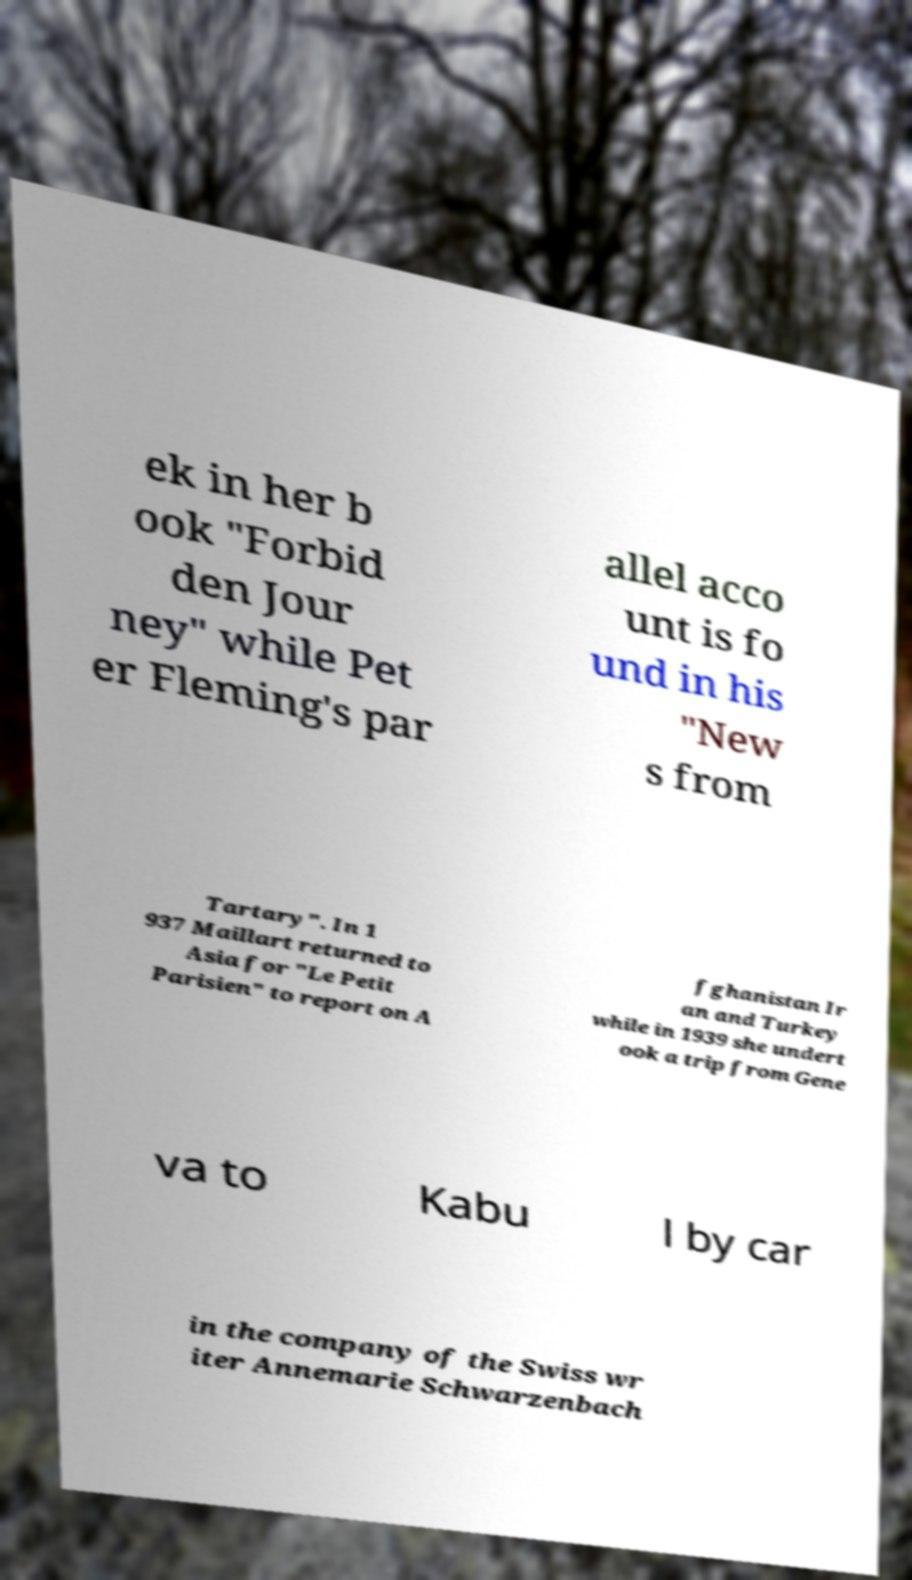I need the written content from this picture converted into text. Can you do that? ek in her b ook "Forbid den Jour ney" while Pet er Fleming's par allel acco unt is fo und in his "New s from Tartary". In 1 937 Maillart returned to Asia for "Le Petit Parisien" to report on A fghanistan Ir an and Turkey while in 1939 she undert ook a trip from Gene va to Kabu l by car in the company of the Swiss wr iter Annemarie Schwarzenbach 